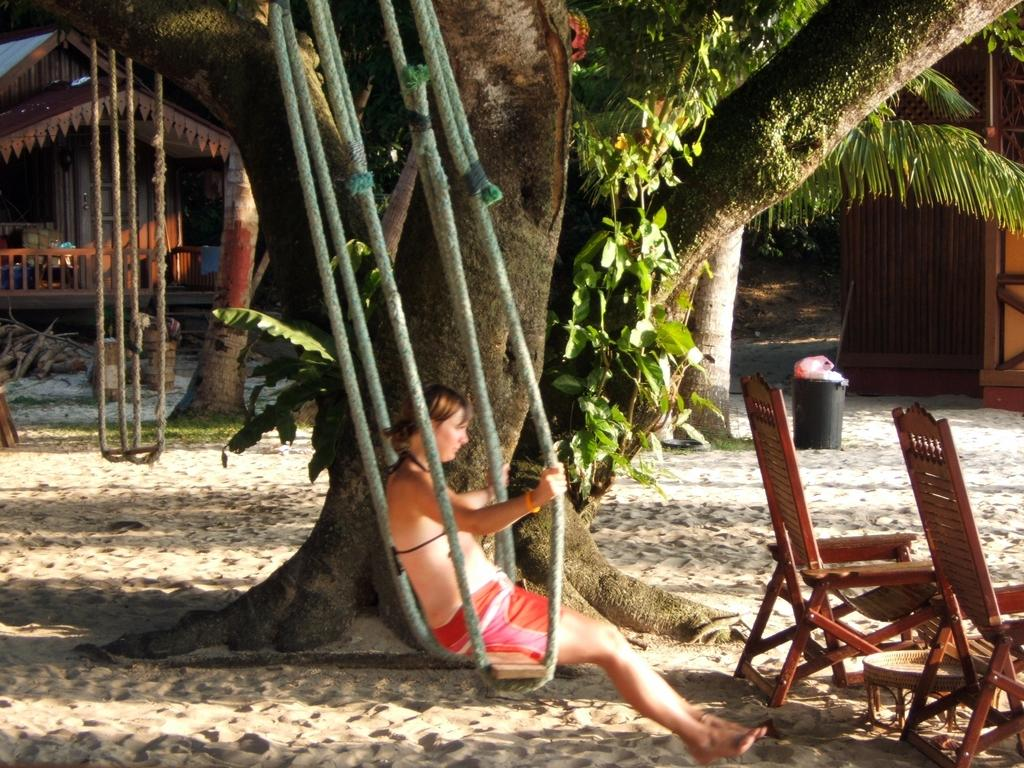What is the woman in the image doing? The woman is sitting on a swing in the image. How many chairs are visible in the image? There are 2 chairs in the image. What can be seen in the background of the image? There are 2 houses, trees, and a garbage bin in the background of the image. Is there another swing visible in the image? Yes, there is another swing in the background of the image. What type of goat is standing next to the woman on the swing? There is no goat present in the image; the woman is sitting on a swing by herself. What is the farmer doing in the image? There is no farmer present in the image. How many fingers can be seen on the woman's hand in the image? The image does not show the woman's hand or any fingers. 